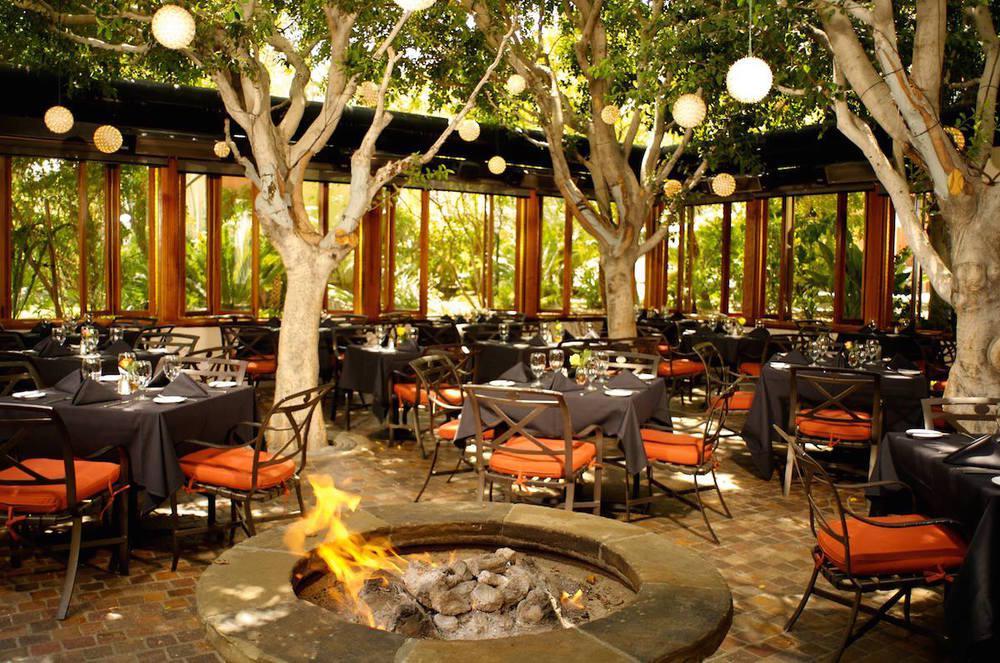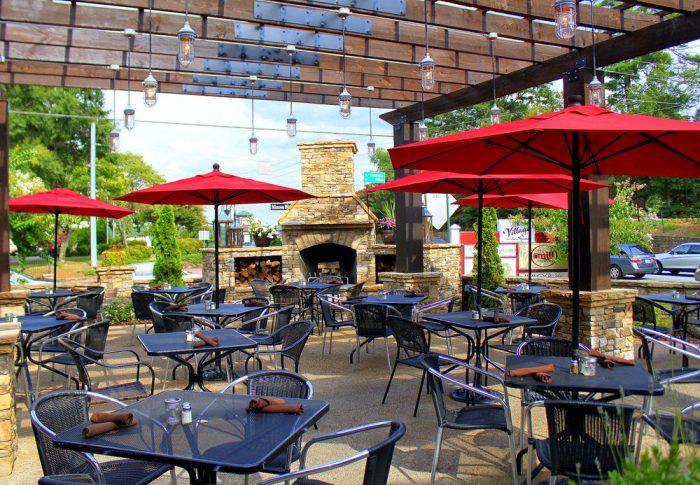The first image is the image on the left, the second image is the image on the right. Considering the images on both sides, is "Umbrellas are set up over a dining area in the image on the right." valid? Answer yes or no. Yes. The first image is the image on the left, the second image is the image on the right. Considering the images on both sides, is "There area at least six tables covered in white linen with four chairs around them." valid? Answer yes or no. No. 